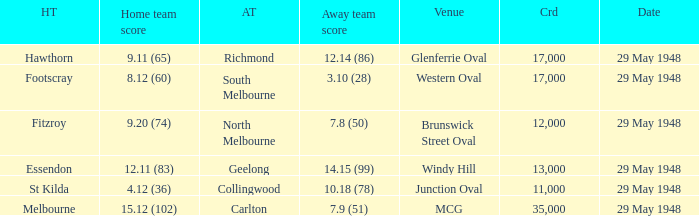During melbourne's home game, who was the away team? Carlton. 